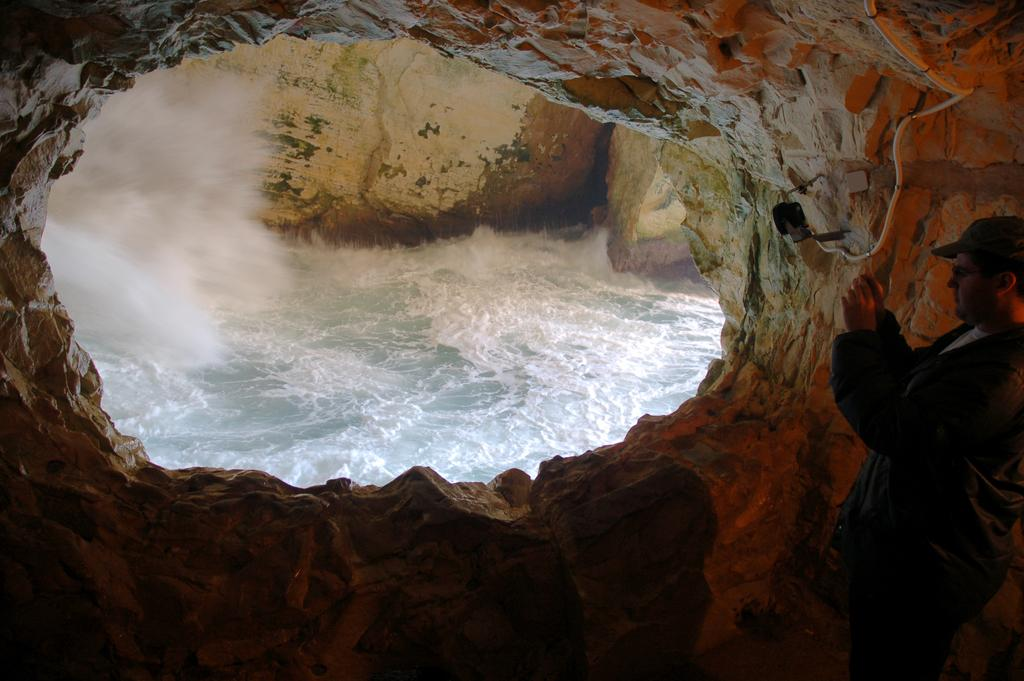What location is depicted in the image? The image appears to depict the Hanikra place. Can you describe the person in the image? There is a man standing on the right side of the image. What is the man holding in his hands? The man is holding something in his hands, but the specific object is not clear from the image. How many flies can be seen on the man's face in the image? There are no flies visible on the man's face in the image. What type of slope is present in the image? The image does not depict a slope; it shows the Hanikra place, which is a geological formation. 